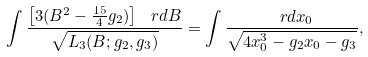Convert formula to latex. <formula><loc_0><loc_0><loc_500><loc_500>\int \frac { \left [ 3 ( B ^ { 2 } - \frac { 1 5 } 4 g _ { 2 } ) \right ] \, \ r d B } { \sqrt { L _ { 3 } ( B ; g _ { 2 } , g _ { 3 } ) } } = \int \frac { \ r d x _ { 0 } } { \sqrt { 4 x _ { 0 } ^ { 3 } - g _ { 2 } x _ { 0 } - g _ { 3 } } } ,</formula> 